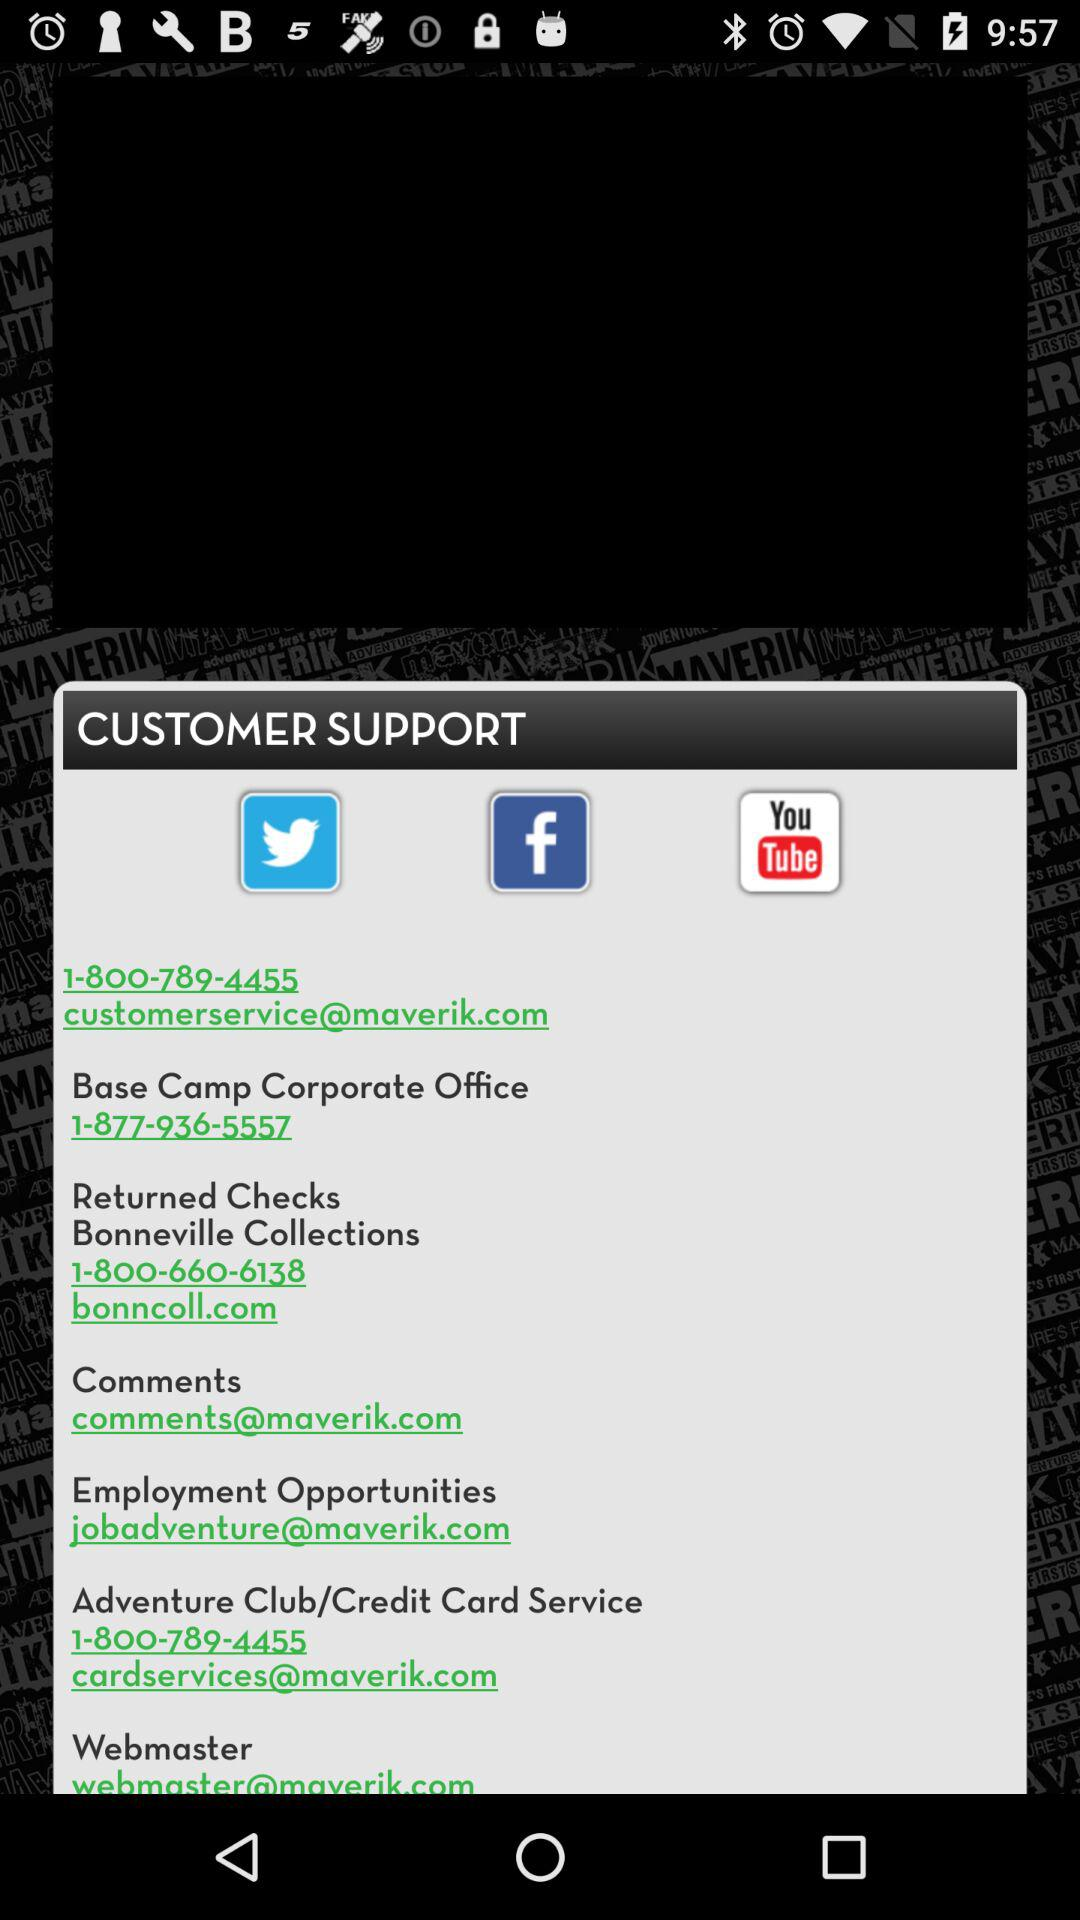What are the options through which we can connect? The options through which you can connect are "Twitter", "Facebook" and "YouTube". 